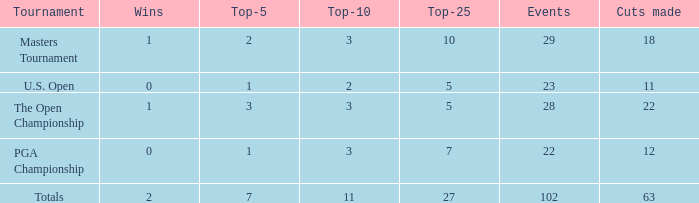How many top 10s linked with 3 top 5s and fewer than 22 cuts made? None. 